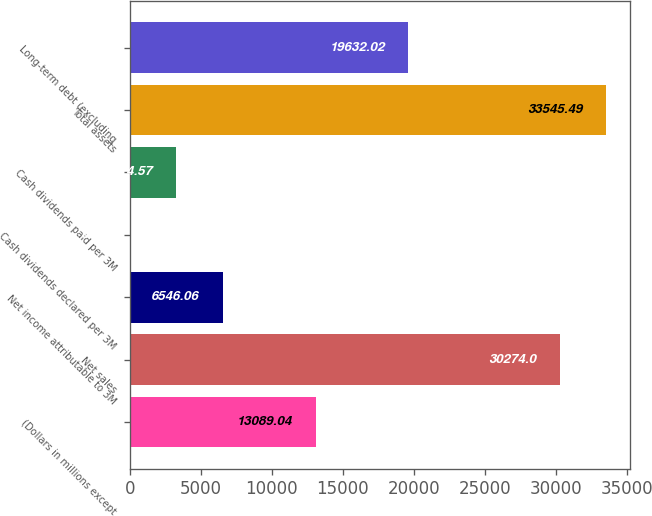<chart> <loc_0><loc_0><loc_500><loc_500><bar_chart><fcel>(Dollars in millions except<fcel>Net sales<fcel>Net income attributable to 3M<fcel>Cash dividends declared per 3M<fcel>Cash dividends paid per 3M<fcel>Total assets<fcel>Long-term debt (excluding<nl><fcel>13089<fcel>30274<fcel>6546.06<fcel>3.08<fcel>3274.57<fcel>33545.5<fcel>19632<nl></chart> 